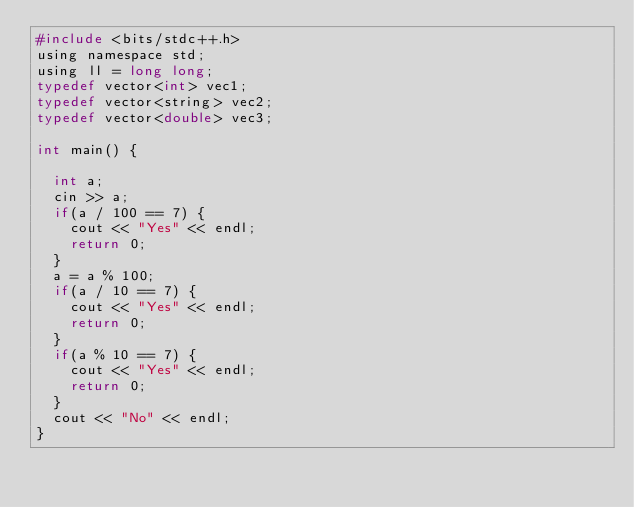Convert code to text. <code><loc_0><loc_0><loc_500><loc_500><_C_>#include <bits/stdc++.h>
using namespace std;
using ll = long long;
typedef vector<int> vec1;
typedef vector<string> vec2;
typedef vector<double> vec3;

int main() {

  int a;
  cin >> a;
  if(a / 100 == 7) {
    cout << "Yes" << endl;
    return 0;
  }
  a = a % 100;
  if(a / 10 == 7) {
    cout << "Yes" << endl;
    return 0;
  }
  if(a % 10 == 7) {
    cout << "Yes" << endl;
    return 0;
  }
  cout << "No" << endl;
}</code> 